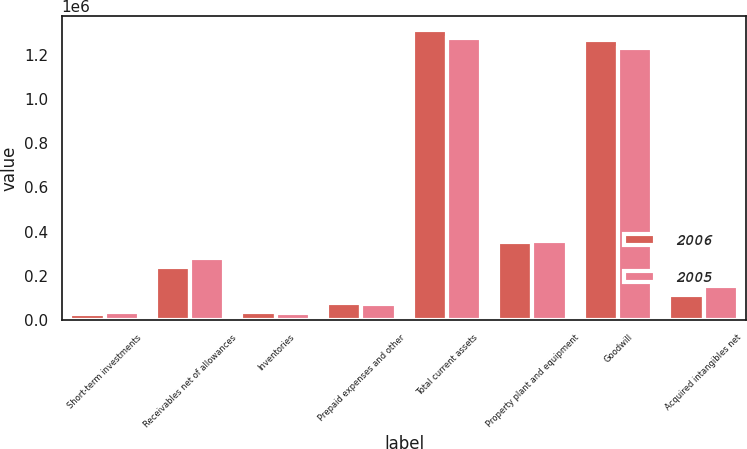Convert chart to OTSL. <chart><loc_0><loc_0><loc_500><loc_500><stacked_bar_chart><ecel><fcel>Short-term investments<fcel>Receivables net of allowances<fcel>Inventories<fcel>Prepaid expenses and other<fcel>Total current assets<fcel>Property plant and equipment<fcel>Goodwill<fcel>Acquired intangibles net<nl><fcel>2006<fcel>24089<fcel>238438<fcel>37179<fcel>77957<fcel>1.312e+06<fcel>354575<fcel>1.26758e+06<fcel>112738<nl><fcel>2005<fcel>33276<fcel>282073<fcel>28902<fcel>70736<fcel>1.2763e+06<fcel>356945<fcel>1.23293e+06<fcel>153847<nl></chart> 